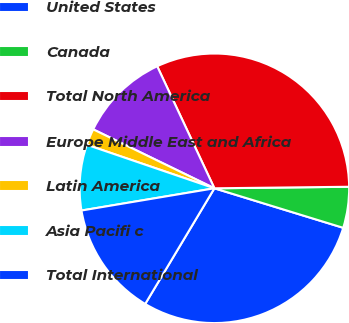Convert chart to OTSL. <chart><loc_0><loc_0><loc_500><loc_500><pie_chart><fcel>United States<fcel>Canada<fcel>Total North America<fcel>Europe Middle East and Africa<fcel>Latin America<fcel>Asia Pacifi c<fcel>Total International<nl><fcel>28.84%<fcel>4.92%<fcel>31.79%<fcel>10.82%<fcel>1.97%<fcel>7.87%<fcel>13.78%<nl></chart> 